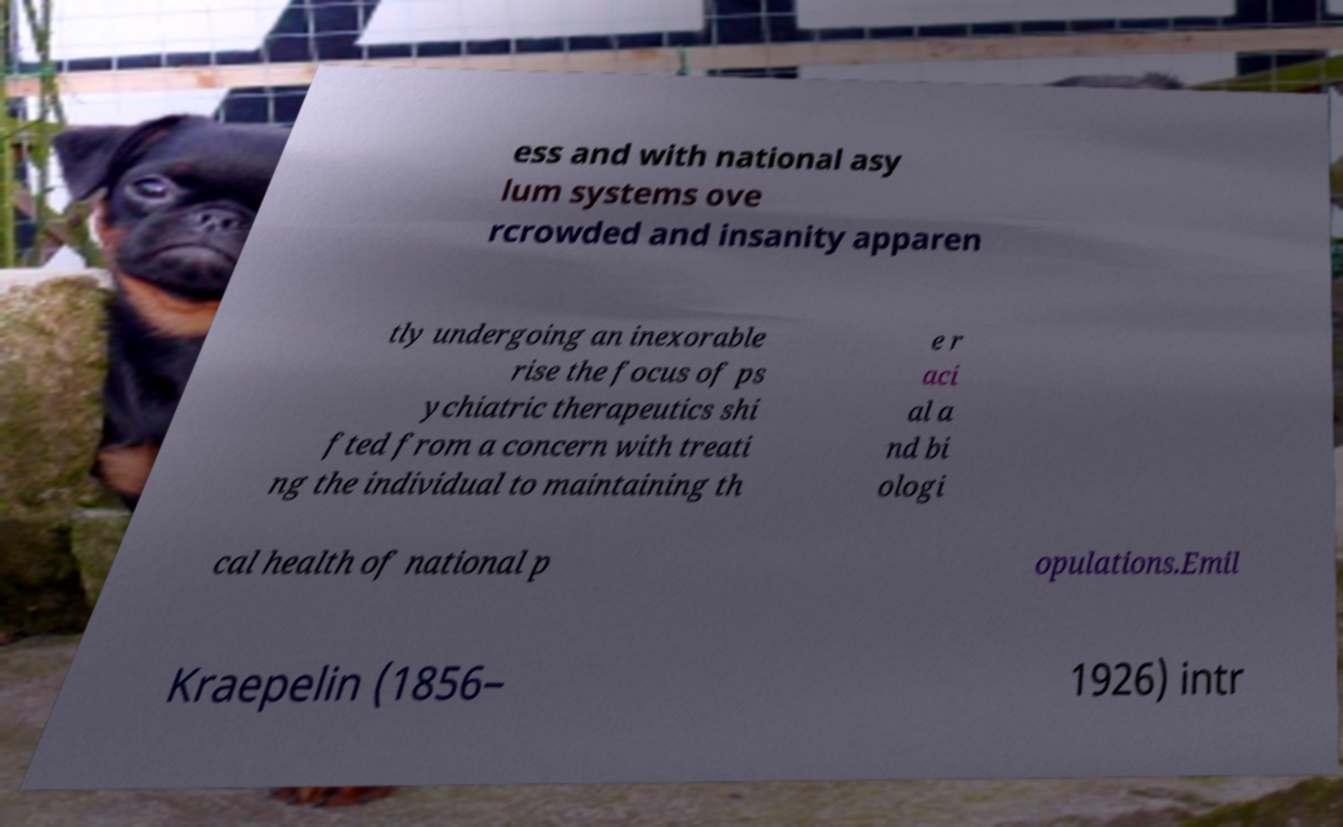Please read and relay the text visible in this image. What does it say? ess and with national asy lum systems ove rcrowded and insanity apparen tly undergoing an inexorable rise the focus of ps ychiatric therapeutics shi fted from a concern with treati ng the individual to maintaining th e r aci al a nd bi ologi cal health of national p opulations.Emil Kraepelin (1856– 1926) intr 